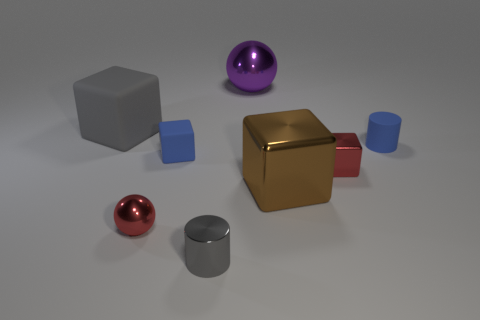There is a small gray metallic cylinder; are there any metal objects on the right side of it?
Ensure brevity in your answer.  Yes. What is the size of the brown block?
Provide a succinct answer. Large. There is another rubber object that is the same shape as the large gray matte object; what is its size?
Offer a very short reply. Small. How many small blue rubber objects are in front of the tiny blue rubber object right of the brown block?
Ensure brevity in your answer.  1. Does the gray object in front of the gray rubber thing have the same material as the small blue object left of the brown metallic block?
Offer a very short reply. No. What number of brown metal things have the same shape as the gray rubber object?
Make the answer very short. 1. What number of large spheres have the same color as the tiny metallic cylinder?
Give a very brief answer. 0. There is a small blue thing on the left side of the big sphere; is its shape the same as the big object left of the large shiny sphere?
Offer a terse response. Yes. There is a metallic ball behind the small matte thing that is on the left side of the tiny gray shiny object; what number of blue cylinders are on the left side of it?
Provide a short and direct response. 0. There is a red object that is to the left of the brown block that is to the left of the small red metallic thing that is behind the large brown metal thing; what is it made of?
Your answer should be very brief. Metal. 